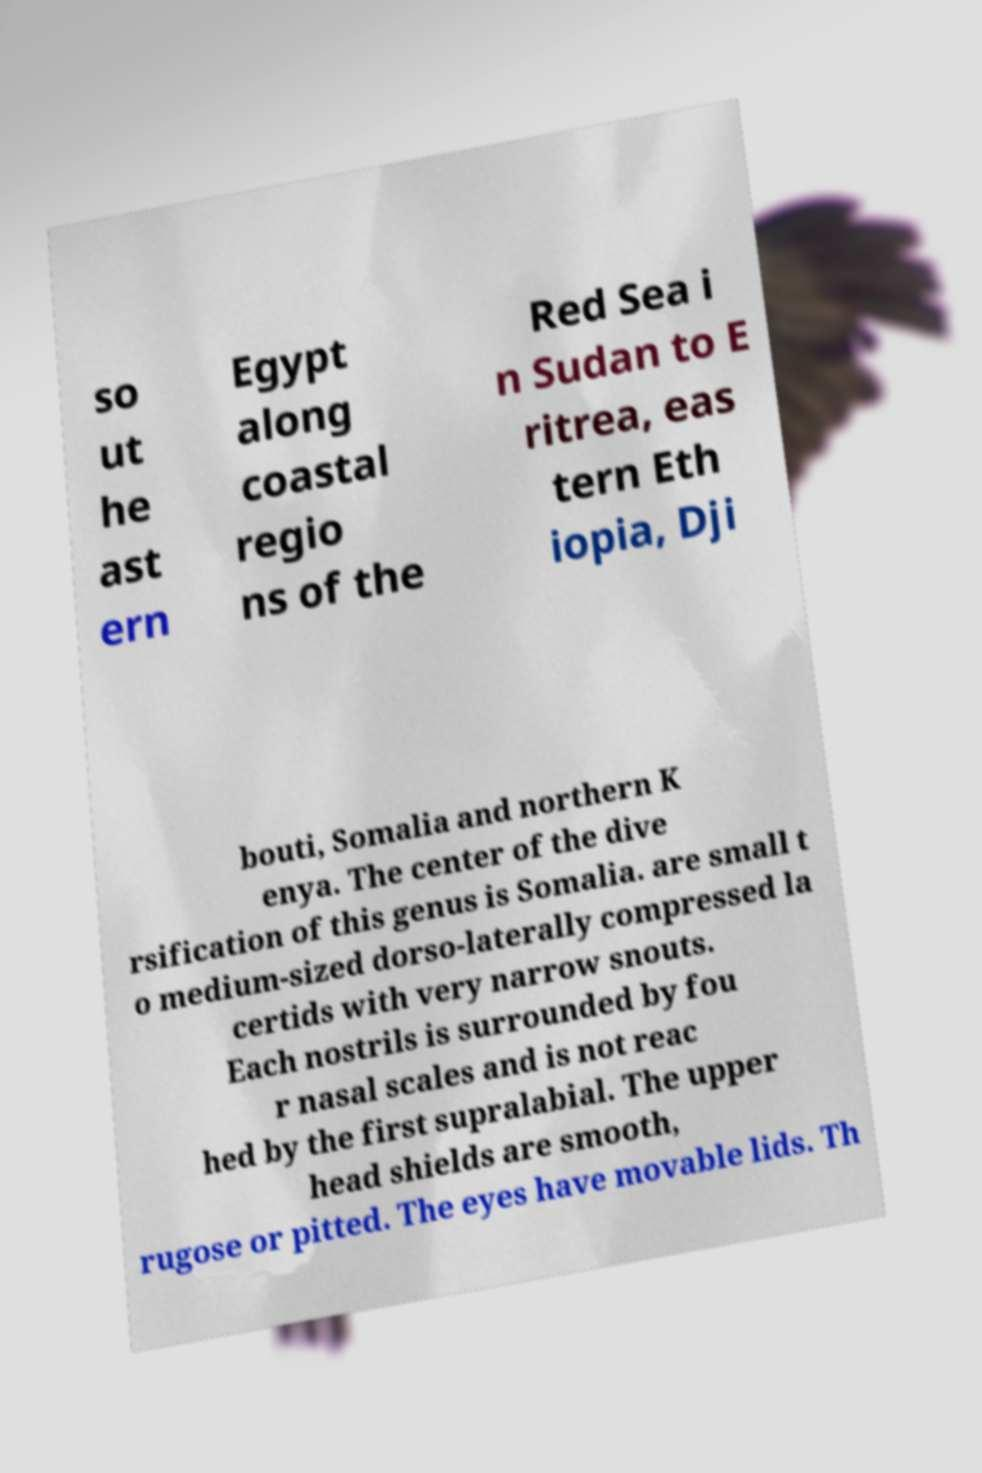Can you accurately transcribe the text from the provided image for me? so ut he ast ern Egypt along coastal regio ns of the Red Sea i n Sudan to E ritrea, eas tern Eth iopia, Dji bouti, Somalia and northern K enya. The center of the dive rsification of this genus is Somalia. are small t o medium-sized dorso-laterally compressed la certids with very narrow snouts. Each nostrils is surrounded by fou r nasal scales and is not reac hed by the first supralabial. The upper head shields are smooth, rugose or pitted. The eyes have movable lids. Th 